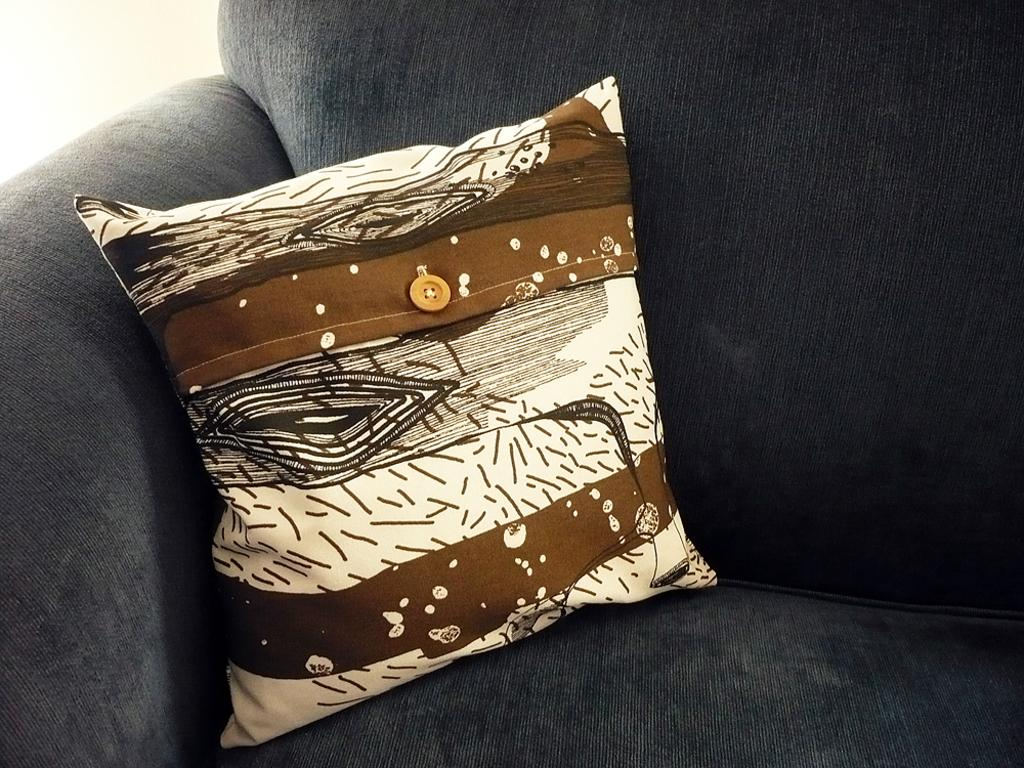What type of furniture is in the image? There is a grey color sofa in the image. What is placed on the sofa? There is a brown-white color pillow on the sofa. What type of structure is the mother using to pump water in the image? There is no structure, mother, or pump present in the image. 